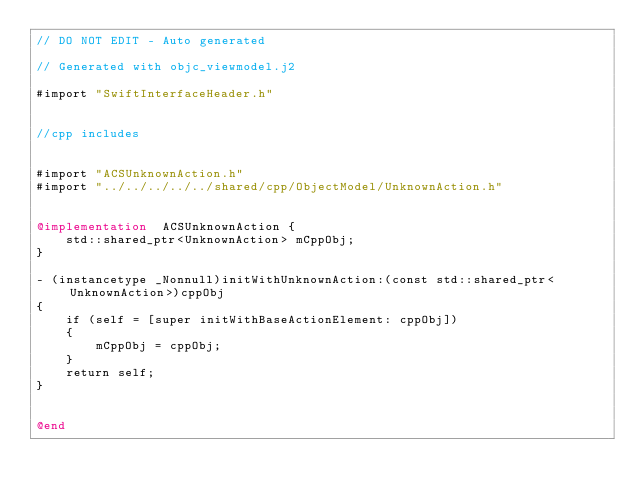<code> <loc_0><loc_0><loc_500><loc_500><_ObjectiveC_>// DO NOT EDIT - Auto generated

// Generated with objc_viewmodel.j2

#import "SwiftInterfaceHeader.h"


//cpp includes


#import "ACSUnknownAction.h"
#import "../../../../../shared/cpp/ObjectModel/UnknownAction.h"


@implementation  ACSUnknownAction {
    std::shared_ptr<UnknownAction> mCppObj;
}

- (instancetype _Nonnull)initWithUnknownAction:(const std::shared_ptr<UnknownAction>)cppObj
{
    if (self = [super initWithBaseActionElement: cppObj])
    {
        mCppObj = cppObj;
    }
    return self;
}


@end
</code> 